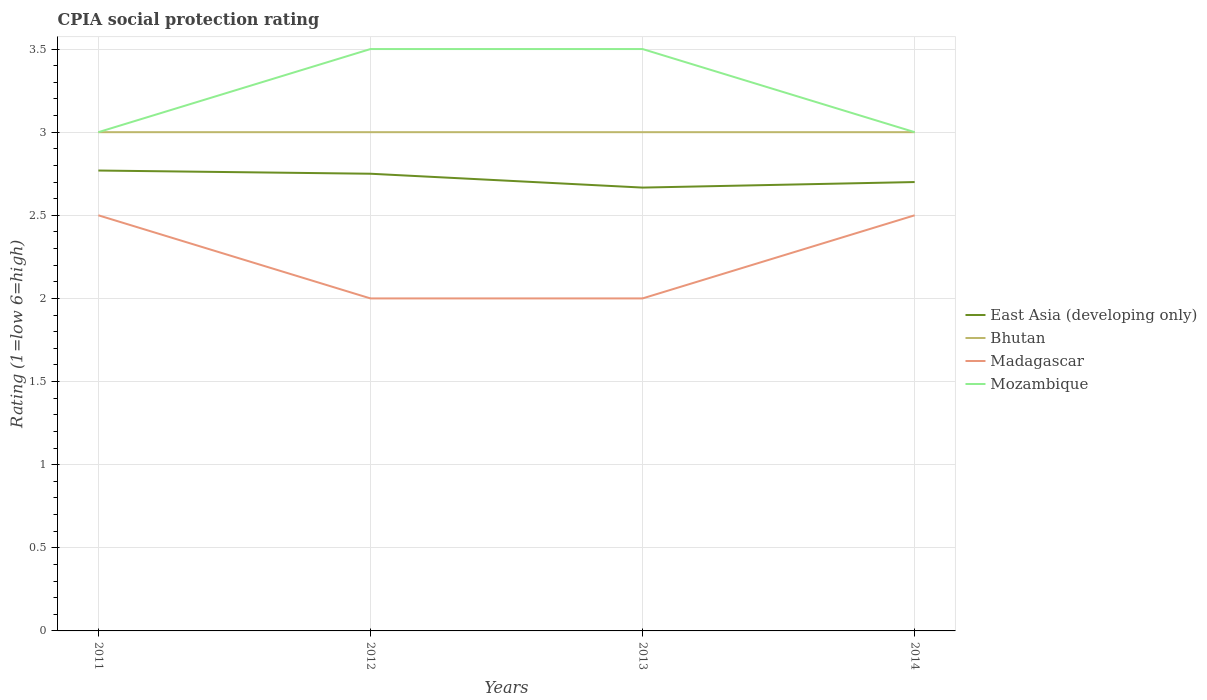Does the line corresponding to East Asia (developing only) intersect with the line corresponding to Mozambique?
Your answer should be compact. No. What is the difference between the highest and the lowest CPIA rating in Madagascar?
Offer a terse response. 2. How many lines are there?
Give a very brief answer. 4. How many years are there in the graph?
Make the answer very short. 4. Where does the legend appear in the graph?
Keep it short and to the point. Center right. How are the legend labels stacked?
Offer a terse response. Vertical. What is the title of the graph?
Offer a very short reply. CPIA social protection rating. Does "Saudi Arabia" appear as one of the legend labels in the graph?
Provide a succinct answer. No. What is the label or title of the X-axis?
Provide a succinct answer. Years. What is the label or title of the Y-axis?
Offer a terse response. Rating (1=low 6=high). What is the Rating (1=low 6=high) of East Asia (developing only) in 2011?
Your response must be concise. 2.77. What is the Rating (1=low 6=high) in Bhutan in 2011?
Make the answer very short. 3. What is the Rating (1=low 6=high) of Mozambique in 2011?
Keep it short and to the point. 3. What is the Rating (1=low 6=high) in East Asia (developing only) in 2012?
Keep it short and to the point. 2.75. What is the Rating (1=low 6=high) of Mozambique in 2012?
Your answer should be compact. 3.5. What is the Rating (1=low 6=high) of East Asia (developing only) in 2013?
Give a very brief answer. 2.67. What is the Rating (1=low 6=high) in Bhutan in 2013?
Ensure brevity in your answer.  3. What is the Rating (1=low 6=high) of East Asia (developing only) in 2014?
Give a very brief answer. 2.7. What is the Rating (1=low 6=high) in Bhutan in 2014?
Offer a very short reply. 3. What is the Rating (1=low 6=high) in Mozambique in 2014?
Offer a very short reply. 3. Across all years, what is the maximum Rating (1=low 6=high) of East Asia (developing only)?
Offer a very short reply. 2.77. Across all years, what is the maximum Rating (1=low 6=high) in Bhutan?
Make the answer very short. 3. Across all years, what is the maximum Rating (1=low 6=high) in Madagascar?
Make the answer very short. 2.5. Across all years, what is the minimum Rating (1=low 6=high) in East Asia (developing only)?
Provide a succinct answer. 2.67. Across all years, what is the minimum Rating (1=low 6=high) of Bhutan?
Your response must be concise. 3. What is the total Rating (1=low 6=high) in East Asia (developing only) in the graph?
Your answer should be very brief. 10.89. What is the total Rating (1=low 6=high) of Bhutan in the graph?
Provide a succinct answer. 12. What is the difference between the Rating (1=low 6=high) in East Asia (developing only) in 2011 and that in 2012?
Ensure brevity in your answer.  0.02. What is the difference between the Rating (1=low 6=high) in Madagascar in 2011 and that in 2012?
Your answer should be very brief. 0.5. What is the difference between the Rating (1=low 6=high) of Mozambique in 2011 and that in 2012?
Offer a terse response. -0.5. What is the difference between the Rating (1=low 6=high) in East Asia (developing only) in 2011 and that in 2013?
Your answer should be compact. 0.1. What is the difference between the Rating (1=low 6=high) of Bhutan in 2011 and that in 2013?
Provide a succinct answer. 0. What is the difference between the Rating (1=low 6=high) in Mozambique in 2011 and that in 2013?
Provide a short and direct response. -0.5. What is the difference between the Rating (1=low 6=high) in East Asia (developing only) in 2011 and that in 2014?
Offer a terse response. 0.07. What is the difference between the Rating (1=low 6=high) in Bhutan in 2011 and that in 2014?
Your answer should be very brief. 0. What is the difference between the Rating (1=low 6=high) of Mozambique in 2011 and that in 2014?
Provide a succinct answer. 0. What is the difference between the Rating (1=low 6=high) in East Asia (developing only) in 2012 and that in 2013?
Give a very brief answer. 0.08. What is the difference between the Rating (1=low 6=high) of Madagascar in 2012 and that in 2013?
Ensure brevity in your answer.  0. What is the difference between the Rating (1=low 6=high) in East Asia (developing only) in 2012 and that in 2014?
Your answer should be very brief. 0.05. What is the difference between the Rating (1=low 6=high) of Bhutan in 2012 and that in 2014?
Keep it short and to the point. 0. What is the difference between the Rating (1=low 6=high) of Madagascar in 2012 and that in 2014?
Keep it short and to the point. -0.5. What is the difference between the Rating (1=low 6=high) of East Asia (developing only) in 2013 and that in 2014?
Give a very brief answer. -0.03. What is the difference between the Rating (1=low 6=high) of Madagascar in 2013 and that in 2014?
Your response must be concise. -0.5. What is the difference between the Rating (1=low 6=high) of Mozambique in 2013 and that in 2014?
Provide a succinct answer. 0.5. What is the difference between the Rating (1=low 6=high) of East Asia (developing only) in 2011 and the Rating (1=low 6=high) of Bhutan in 2012?
Make the answer very short. -0.23. What is the difference between the Rating (1=low 6=high) of East Asia (developing only) in 2011 and the Rating (1=low 6=high) of Madagascar in 2012?
Make the answer very short. 0.77. What is the difference between the Rating (1=low 6=high) of East Asia (developing only) in 2011 and the Rating (1=low 6=high) of Mozambique in 2012?
Offer a terse response. -0.73. What is the difference between the Rating (1=low 6=high) in East Asia (developing only) in 2011 and the Rating (1=low 6=high) in Bhutan in 2013?
Keep it short and to the point. -0.23. What is the difference between the Rating (1=low 6=high) of East Asia (developing only) in 2011 and the Rating (1=low 6=high) of Madagascar in 2013?
Ensure brevity in your answer.  0.77. What is the difference between the Rating (1=low 6=high) of East Asia (developing only) in 2011 and the Rating (1=low 6=high) of Mozambique in 2013?
Make the answer very short. -0.73. What is the difference between the Rating (1=low 6=high) in Bhutan in 2011 and the Rating (1=low 6=high) in Madagascar in 2013?
Provide a short and direct response. 1. What is the difference between the Rating (1=low 6=high) in Bhutan in 2011 and the Rating (1=low 6=high) in Mozambique in 2013?
Keep it short and to the point. -0.5. What is the difference between the Rating (1=low 6=high) in East Asia (developing only) in 2011 and the Rating (1=low 6=high) in Bhutan in 2014?
Your response must be concise. -0.23. What is the difference between the Rating (1=low 6=high) in East Asia (developing only) in 2011 and the Rating (1=low 6=high) in Madagascar in 2014?
Keep it short and to the point. 0.27. What is the difference between the Rating (1=low 6=high) of East Asia (developing only) in 2011 and the Rating (1=low 6=high) of Mozambique in 2014?
Offer a terse response. -0.23. What is the difference between the Rating (1=low 6=high) of East Asia (developing only) in 2012 and the Rating (1=low 6=high) of Bhutan in 2013?
Your answer should be compact. -0.25. What is the difference between the Rating (1=low 6=high) in East Asia (developing only) in 2012 and the Rating (1=low 6=high) in Mozambique in 2013?
Ensure brevity in your answer.  -0.75. What is the difference between the Rating (1=low 6=high) of Bhutan in 2012 and the Rating (1=low 6=high) of Madagascar in 2013?
Offer a terse response. 1. What is the difference between the Rating (1=low 6=high) of East Asia (developing only) in 2012 and the Rating (1=low 6=high) of Bhutan in 2014?
Make the answer very short. -0.25. What is the difference between the Rating (1=low 6=high) in East Asia (developing only) in 2012 and the Rating (1=low 6=high) in Madagascar in 2014?
Make the answer very short. 0.25. What is the difference between the Rating (1=low 6=high) of Bhutan in 2012 and the Rating (1=low 6=high) of Madagascar in 2014?
Provide a short and direct response. 0.5. What is the difference between the Rating (1=low 6=high) in East Asia (developing only) in 2013 and the Rating (1=low 6=high) in Bhutan in 2014?
Your answer should be very brief. -0.33. What is the difference between the Rating (1=low 6=high) of East Asia (developing only) in 2013 and the Rating (1=low 6=high) of Madagascar in 2014?
Give a very brief answer. 0.17. What is the difference between the Rating (1=low 6=high) in Bhutan in 2013 and the Rating (1=low 6=high) in Madagascar in 2014?
Provide a short and direct response. 0.5. What is the average Rating (1=low 6=high) of East Asia (developing only) per year?
Provide a succinct answer. 2.72. What is the average Rating (1=low 6=high) of Madagascar per year?
Offer a very short reply. 2.25. What is the average Rating (1=low 6=high) in Mozambique per year?
Provide a succinct answer. 3.25. In the year 2011, what is the difference between the Rating (1=low 6=high) in East Asia (developing only) and Rating (1=low 6=high) in Bhutan?
Your answer should be very brief. -0.23. In the year 2011, what is the difference between the Rating (1=low 6=high) in East Asia (developing only) and Rating (1=low 6=high) in Madagascar?
Your response must be concise. 0.27. In the year 2011, what is the difference between the Rating (1=low 6=high) of East Asia (developing only) and Rating (1=low 6=high) of Mozambique?
Keep it short and to the point. -0.23. In the year 2011, what is the difference between the Rating (1=low 6=high) of Bhutan and Rating (1=low 6=high) of Madagascar?
Your response must be concise. 0.5. In the year 2011, what is the difference between the Rating (1=low 6=high) in Bhutan and Rating (1=low 6=high) in Mozambique?
Make the answer very short. 0. In the year 2011, what is the difference between the Rating (1=low 6=high) of Madagascar and Rating (1=low 6=high) of Mozambique?
Offer a very short reply. -0.5. In the year 2012, what is the difference between the Rating (1=low 6=high) in East Asia (developing only) and Rating (1=low 6=high) in Mozambique?
Give a very brief answer. -0.75. In the year 2012, what is the difference between the Rating (1=low 6=high) in Bhutan and Rating (1=low 6=high) in Madagascar?
Offer a terse response. 1. In the year 2013, what is the difference between the Rating (1=low 6=high) in East Asia (developing only) and Rating (1=low 6=high) in Mozambique?
Offer a terse response. -0.83. In the year 2013, what is the difference between the Rating (1=low 6=high) of Bhutan and Rating (1=low 6=high) of Mozambique?
Keep it short and to the point. -0.5. In the year 2014, what is the difference between the Rating (1=low 6=high) of East Asia (developing only) and Rating (1=low 6=high) of Madagascar?
Offer a terse response. 0.2. In the year 2014, what is the difference between the Rating (1=low 6=high) in East Asia (developing only) and Rating (1=low 6=high) in Mozambique?
Provide a short and direct response. -0.3. In the year 2014, what is the difference between the Rating (1=low 6=high) in Bhutan and Rating (1=low 6=high) in Mozambique?
Ensure brevity in your answer.  0. What is the ratio of the Rating (1=low 6=high) of East Asia (developing only) in 2011 to that in 2014?
Make the answer very short. 1.03. What is the ratio of the Rating (1=low 6=high) in Madagascar in 2011 to that in 2014?
Give a very brief answer. 1. What is the ratio of the Rating (1=low 6=high) of East Asia (developing only) in 2012 to that in 2013?
Your response must be concise. 1.03. What is the ratio of the Rating (1=low 6=high) in Bhutan in 2012 to that in 2013?
Ensure brevity in your answer.  1. What is the ratio of the Rating (1=low 6=high) of Mozambique in 2012 to that in 2013?
Provide a succinct answer. 1. What is the ratio of the Rating (1=low 6=high) of East Asia (developing only) in 2012 to that in 2014?
Offer a terse response. 1.02. What is the ratio of the Rating (1=low 6=high) in Madagascar in 2012 to that in 2014?
Your answer should be compact. 0.8. What is the ratio of the Rating (1=low 6=high) in Mozambique in 2012 to that in 2014?
Give a very brief answer. 1.17. What is the difference between the highest and the second highest Rating (1=low 6=high) of East Asia (developing only)?
Provide a short and direct response. 0.02. What is the difference between the highest and the second highest Rating (1=low 6=high) of Mozambique?
Give a very brief answer. 0. What is the difference between the highest and the lowest Rating (1=low 6=high) in East Asia (developing only)?
Your answer should be compact. 0.1. What is the difference between the highest and the lowest Rating (1=low 6=high) in Madagascar?
Offer a very short reply. 0.5. What is the difference between the highest and the lowest Rating (1=low 6=high) of Mozambique?
Make the answer very short. 0.5. 